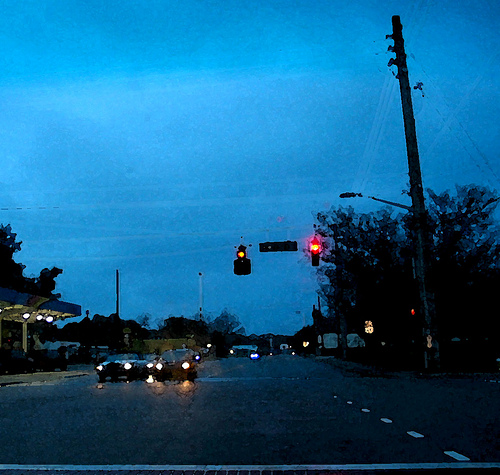What's happening in the scene? In the scene, there is a street intersection during what appears to be dusk or early evening. On the right side, there is a tall streetlight standing prominently. Nearby, two traffic lights are hanging over the intersection. The first traffic light, positioned slightly to the left, is in the center of the image, showing a red signal, while the second one to its right also displays a red signal. Several cars are visible on the road, with their headlights on, indicating that visibility conditions might be low due to the time of day or weather. The surroundings include trees and some buildings, contributing to the urban landscape. 